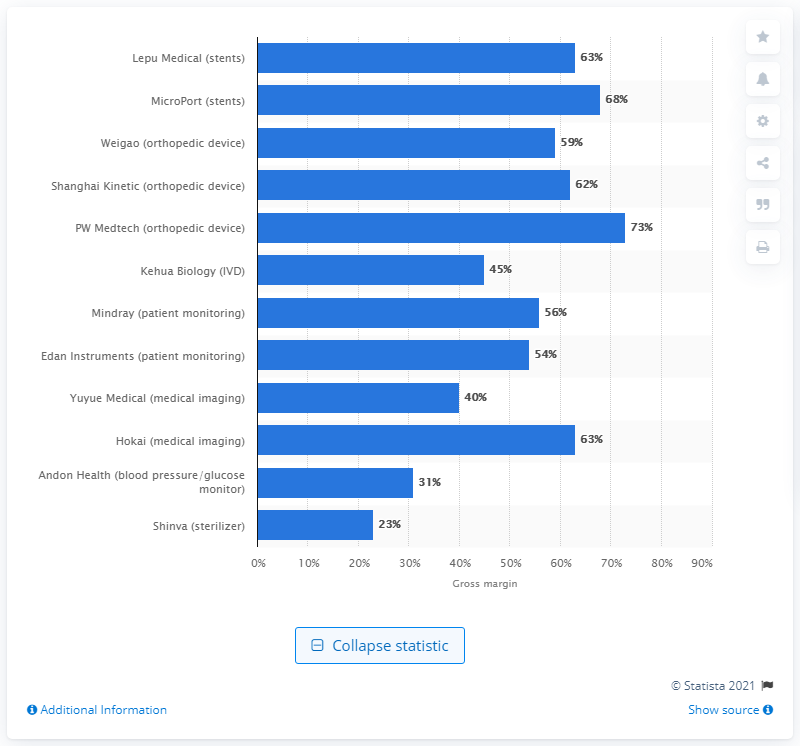Mention a couple of crucial points in this snapshot. In 2014, Shanghai Kinetic's gross margin was 62%. 